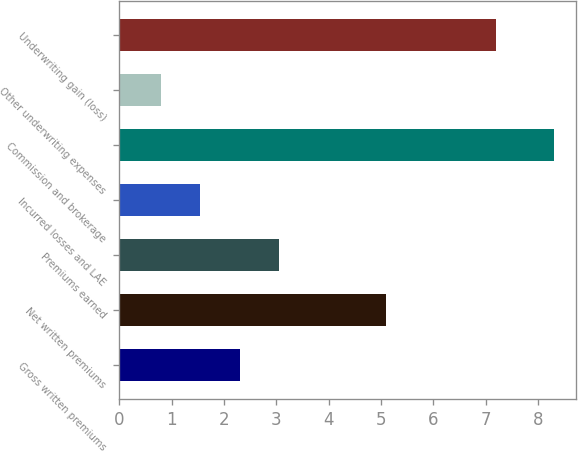Convert chart. <chart><loc_0><loc_0><loc_500><loc_500><bar_chart><fcel>Gross written premiums<fcel>Net written premiums<fcel>Premiums earned<fcel>Incurred losses and LAE<fcel>Commission and brokerage<fcel>Other underwriting expenses<fcel>Underwriting gain (loss)<nl><fcel>2.3<fcel>5.1<fcel>3.05<fcel>1.55<fcel>8.3<fcel>0.8<fcel>7.2<nl></chart> 